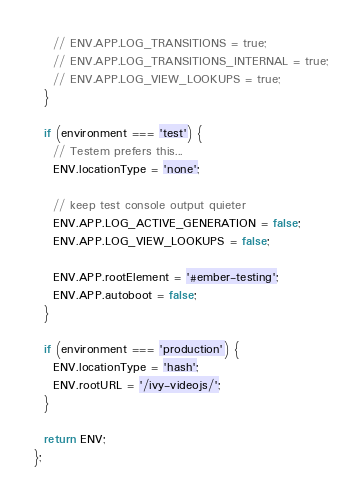<code> <loc_0><loc_0><loc_500><loc_500><_JavaScript_>    // ENV.APP.LOG_TRANSITIONS = true;
    // ENV.APP.LOG_TRANSITIONS_INTERNAL = true;
    // ENV.APP.LOG_VIEW_LOOKUPS = true;
  }

  if (environment === 'test') {
    // Testem prefers this...
    ENV.locationType = 'none';

    // keep test console output quieter
    ENV.APP.LOG_ACTIVE_GENERATION = false;
    ENV.APP.LOG_VIEW_LOOKUPS = false;

    ENV.APP.rootElement = '#ember-testing';
    ENV.APP.autoboot = false;
  }

  if (environment === 'production') {
    ENV.locationType = 'hash';
    ENV.rootURL = '/ivy-videojs/';
  }

  return ENV;
};
</code> 